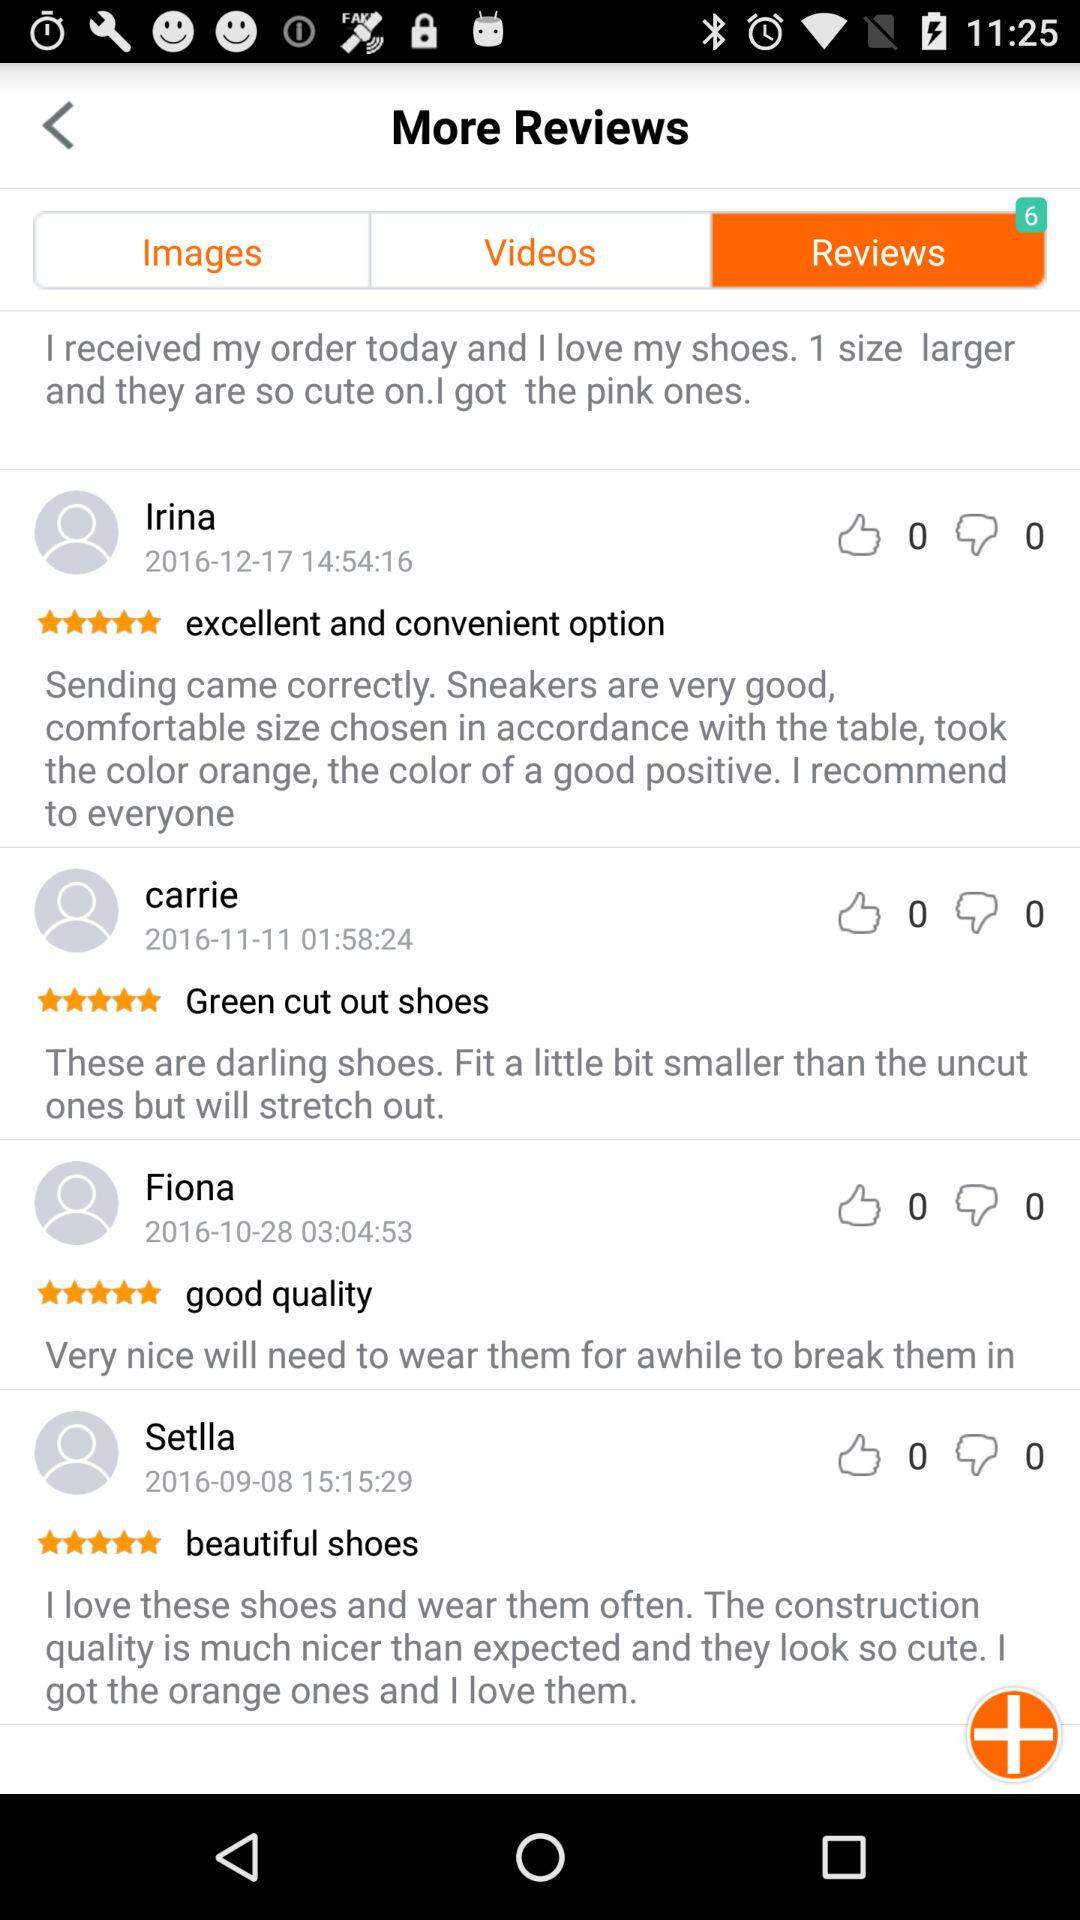What is the rating given by Carrie? The rating given by Carrie is 5 stars. 